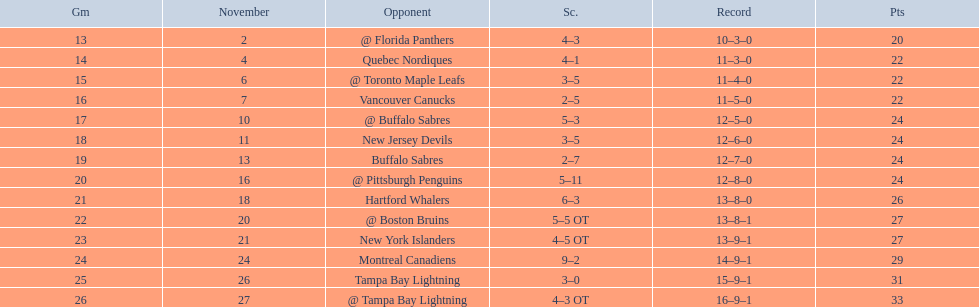What are the teams in the atlantic division? Quebec Nordiques, Vancouver Canucks, New Jersey Devils, Buffalo Sabres, Hartford Whalers, New York Islanders, Montreal Canadiens, Tampa Bay Lightning. Which of those scored fewer points than the philadelphia flyers? Tampa Bay Lightning. 